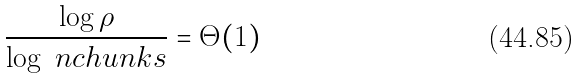Convert formula to latex. <formula><loc_0><loc_0><loc_500><loc_500>\frac { \log \rho } { \log \ n c h u n k s } = \Theta ( 1 )</formula> 